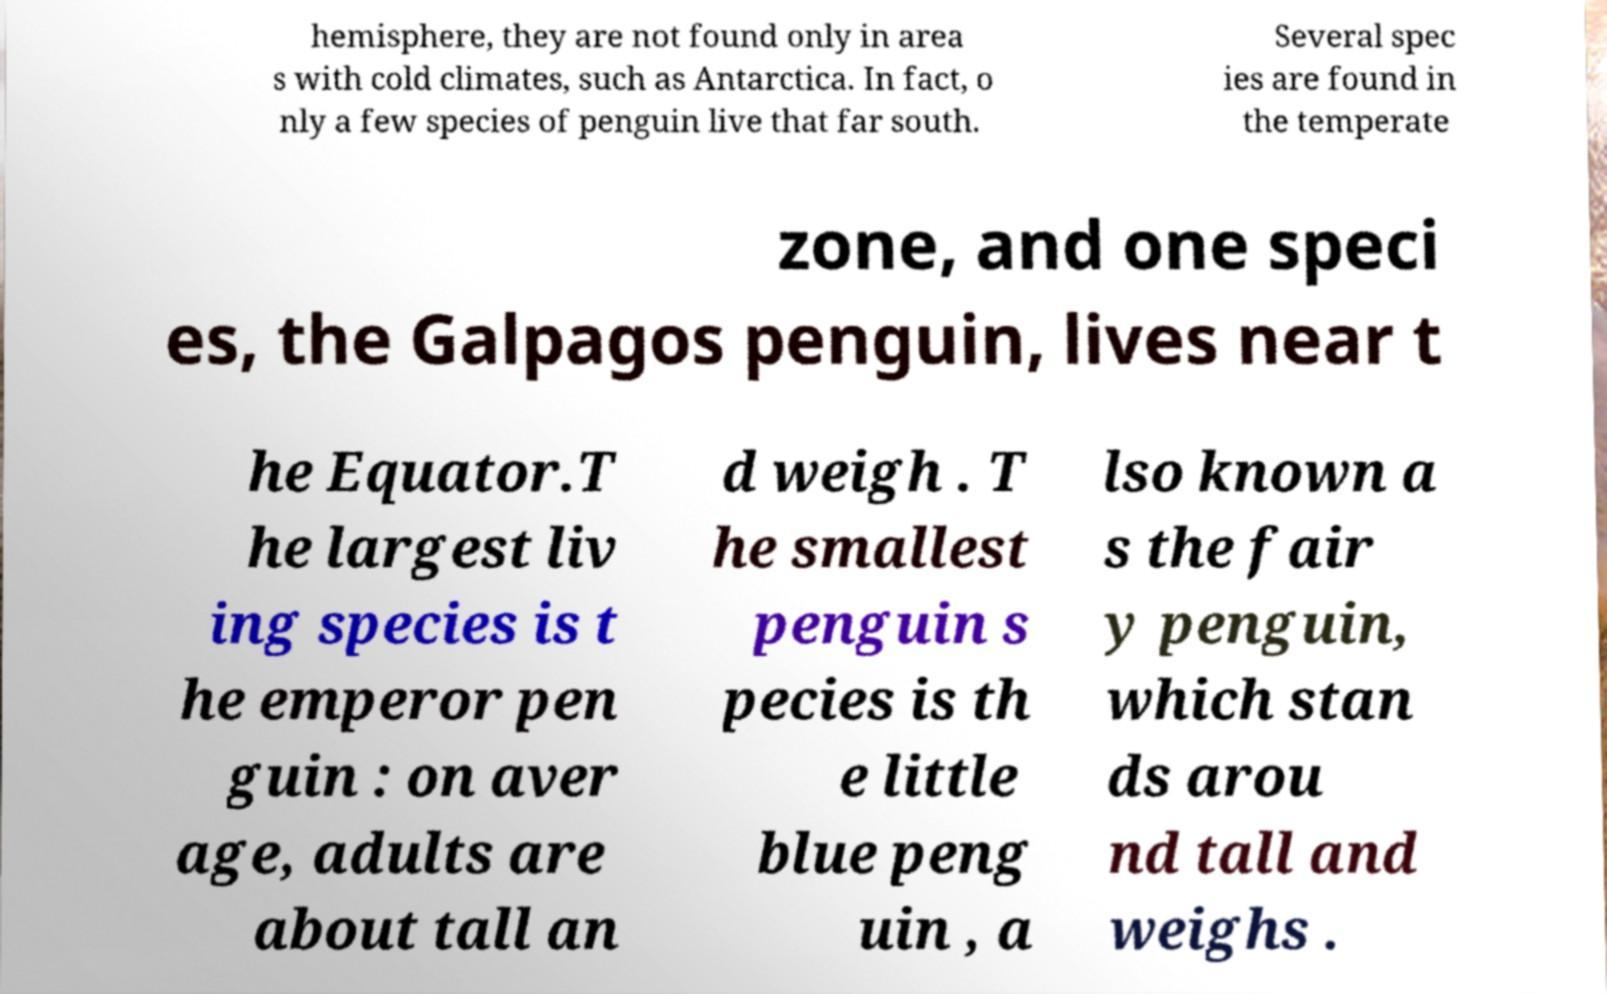Can you read and provide the text displayed in the image?This photo seems to have some interesting text. Can you extract and type it out for me? hemisphere, they are not found only in area s with cold climates, such as Antarctica. In fact, o nly a few species of penguin live that far south. Several spec ies are found in the temperate zone, and one speci es, the Galpagos penguin, lives near t he Equator.T he largest liv ing species is t he emperor pen guin : on aver age, adults are about tall an d weigh . T he smallest penguin s pecies is th e little blue peng uin , a lso known a s the fair y penguin, which stan ds arou nd tall and weighs . 